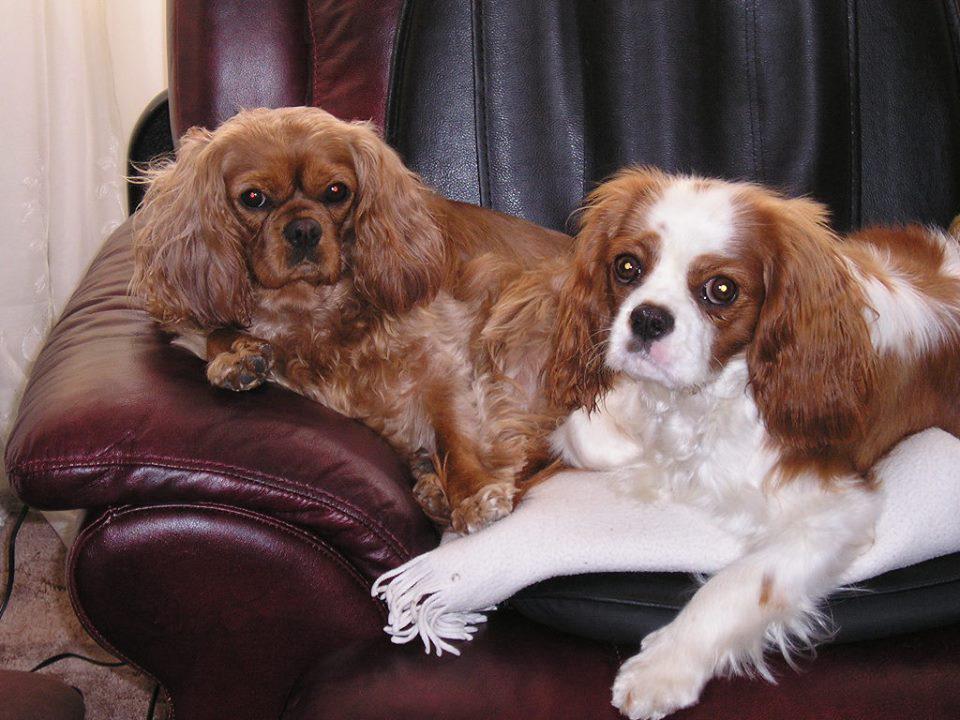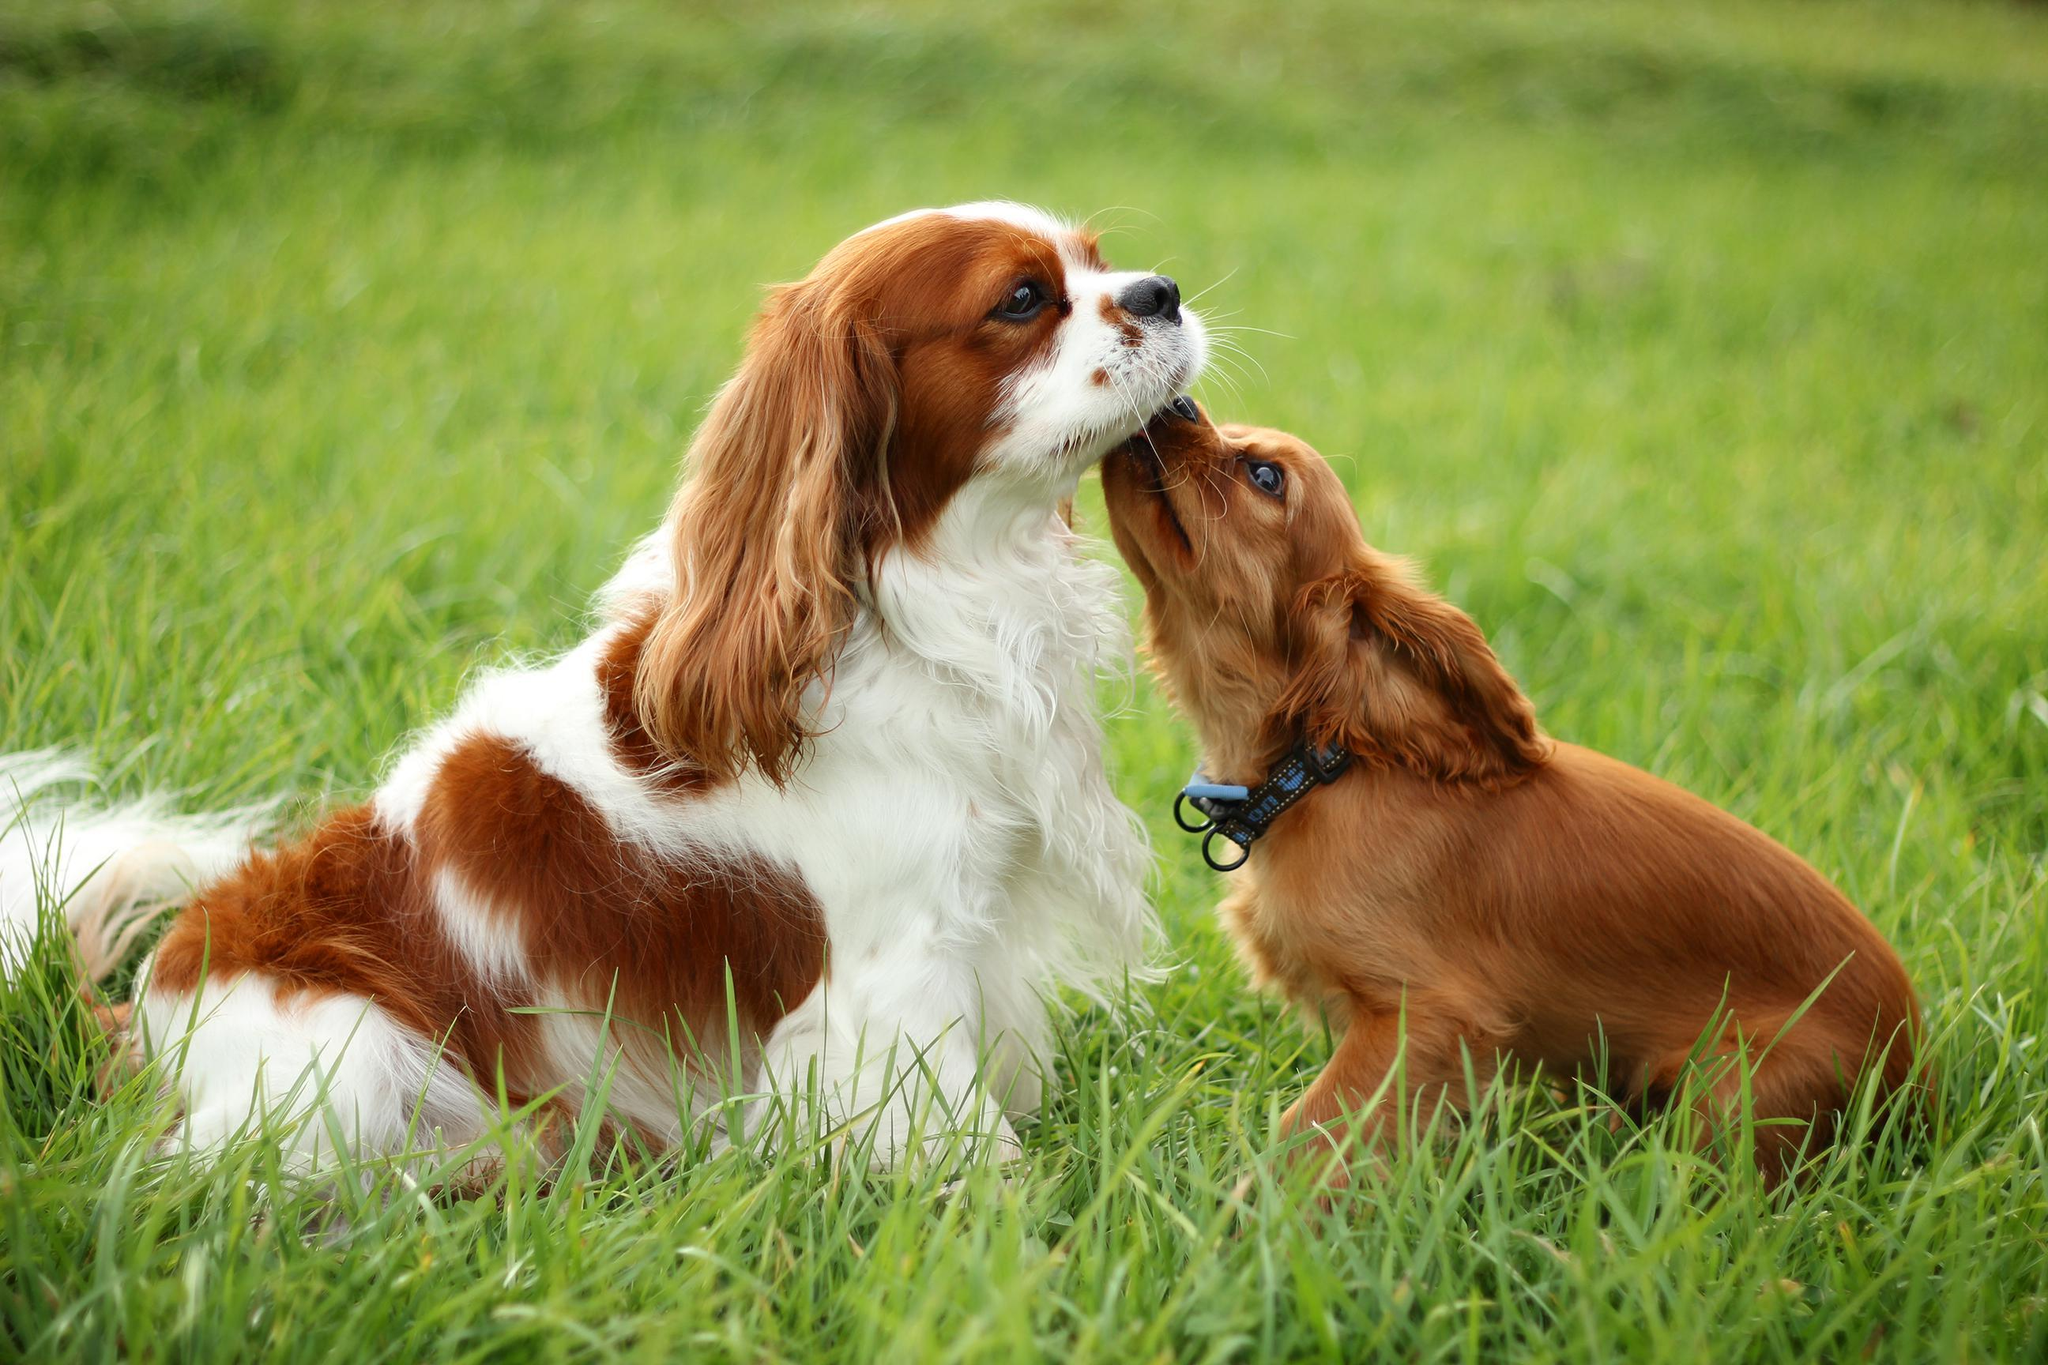The first image is the image on the left, the second image is the image on the right. Evaluate the accuracy of this statement regarding the images: "There are no more than three dogs.". Is it true? Answer yes or no. No. The first image is the image on the left, the second image is the image on the right. Assess this claim about the two images: "There are no more than three dogs.". Correct or not? Answer yes or no. No. 